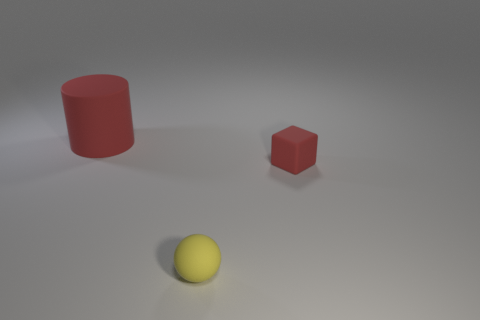There is a yellow sphere to the left of the red thing that is in front of the red matte object that is on the left side of the small red block; what is its material?
Your response must be concise. Rubber. What is the shape of the large object that is the same material as the tiny yellow sphere?
Give a very brief answer. Cylinder. Is there anything else of the same color as the big object?
Offer a terse response. Yes. There is a red object to the right of the red rubber object on the left side of the tiny yellow ball; what number of tiny matte balls are right of it?
Ensure brevity in your answer.  0. How many gray things are either small matte spheres or big rubber cylinders?
Keep it short and to the point. 0. Do the yellow matte sphere and the matte thing that is to the left of the small yellow matte object have the same size?
Keep it short and to the point. No. How many other objects are there of the same size as the rubber cylinder?
Keep it short and to the point. 0. What shape is the red rubber object on the right side of the red rubber object to the left of the red rubber object to the right of the yellow rubber object?
Your response must be concise. Cube. There is a matte object that is both on the left side of the small cube and behind the small yellow matte ball; what shape is it?
Your answer should be compact. Cylinder. What number of things are either tiny blue balls or red matte things that are in front of the cylinder?
Your answer should be very brief. 1. 